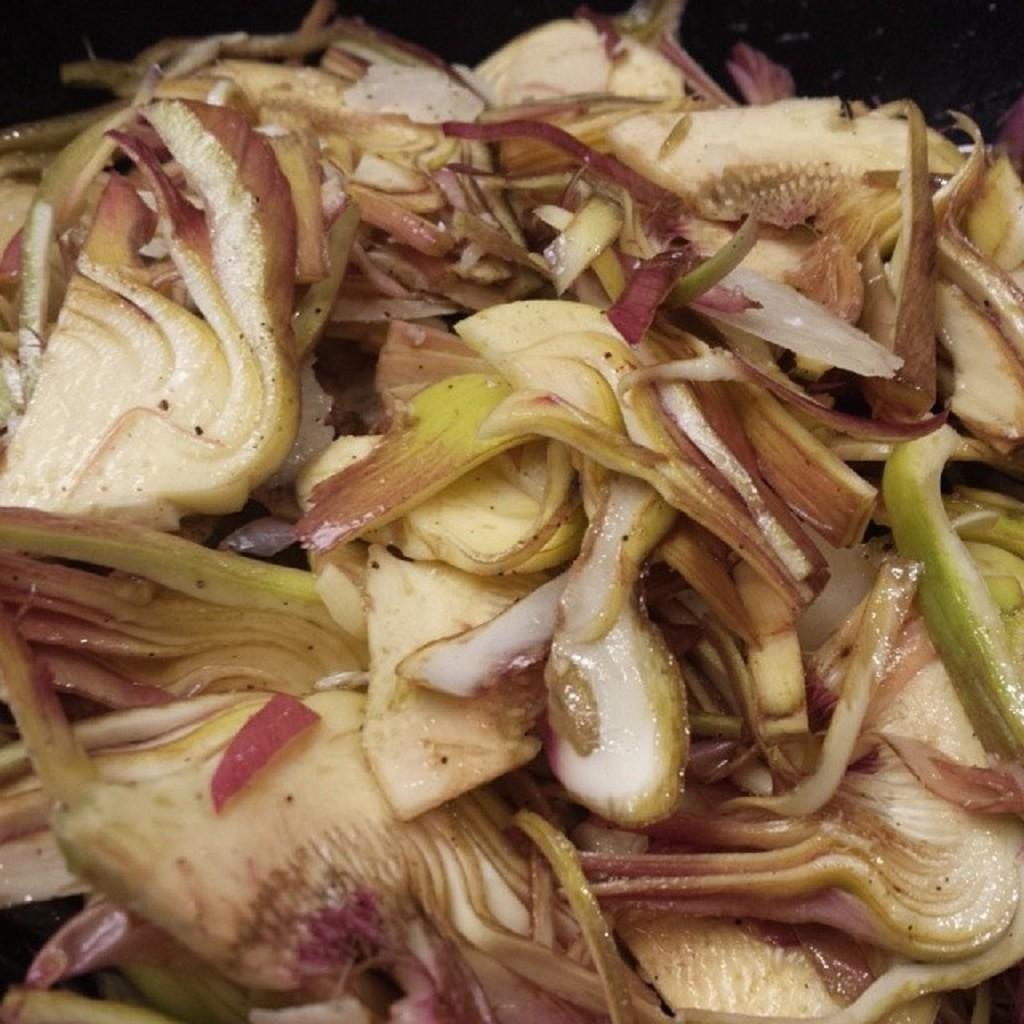What is the main subject of the image? There is a food item in the center of the image. What type of ingredient can be found in the food item? The food item contains onion slices. Are there any other vegetables present in the food item? Yes, the food item contains other vegetable slices. Is there a spade being used to mix the vegetables in the image? There is no spade present in the image, and the vegetables are not being mixed. 